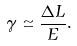<formula> <loc_0><loc_0><loc_500><loc_500>\gamma \simeq \frac { \Delta L } { E } .</formula> 